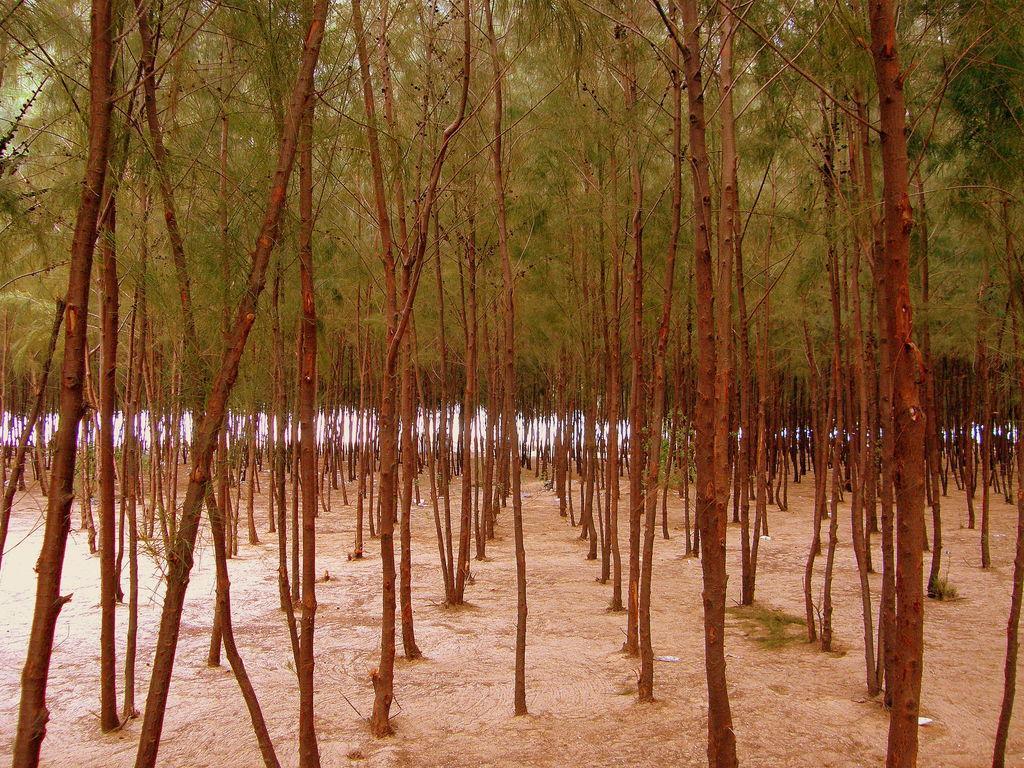How would you summarize this image in a sentence or two? In this image there are trees. At the bottom of the image there is sand. 